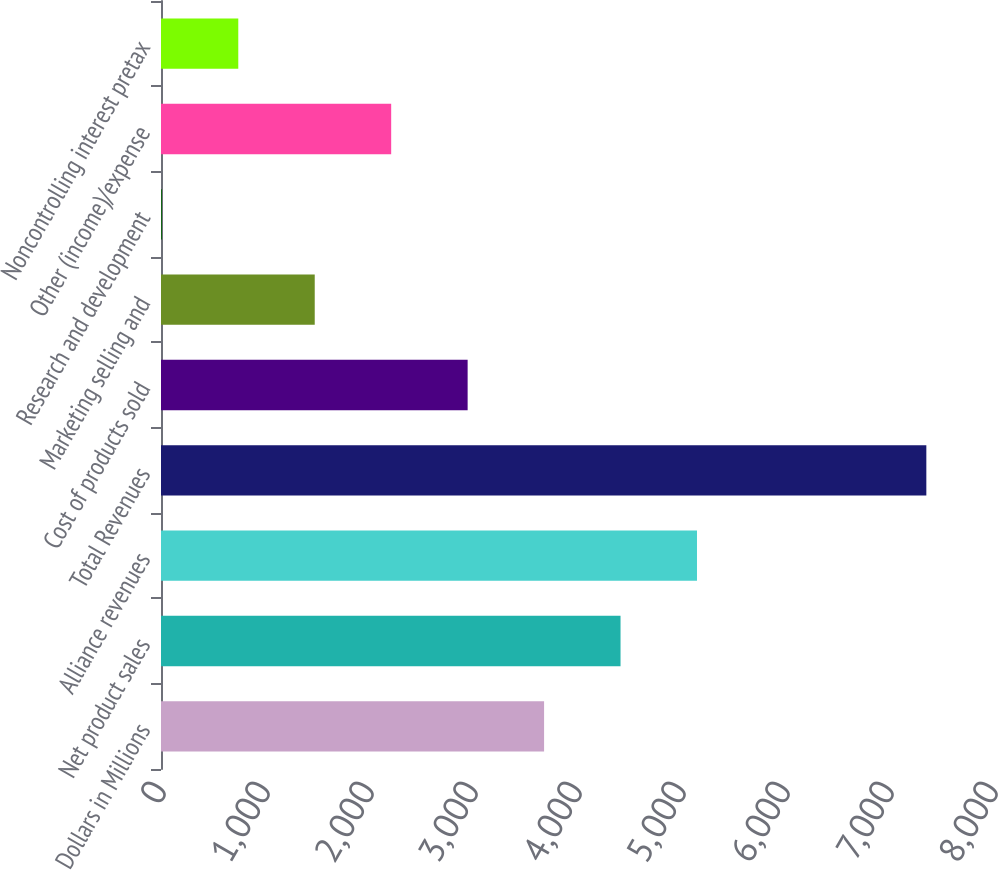<chart> <loc_0><loc_0><loc_500><loc_500><bar_chart><fcel>Dollars in Millions<fcel>Net product sales<fcel>Alliance revenues<fcel>Total Revenues<fcel>Cost of products sold<fcel>Marketing selling and<fcel>Research and development<fcel>Other (income)/expense<fcel>Noncontrolling interest pretax<nl><fcel>3683.5<fcel>4418.6<fcel>5153.7<fcel>7359<fcel>2948.4<fcel>1478.2<fcel>8<fcel>2213.3<fcel>743.1<nl></chart> 